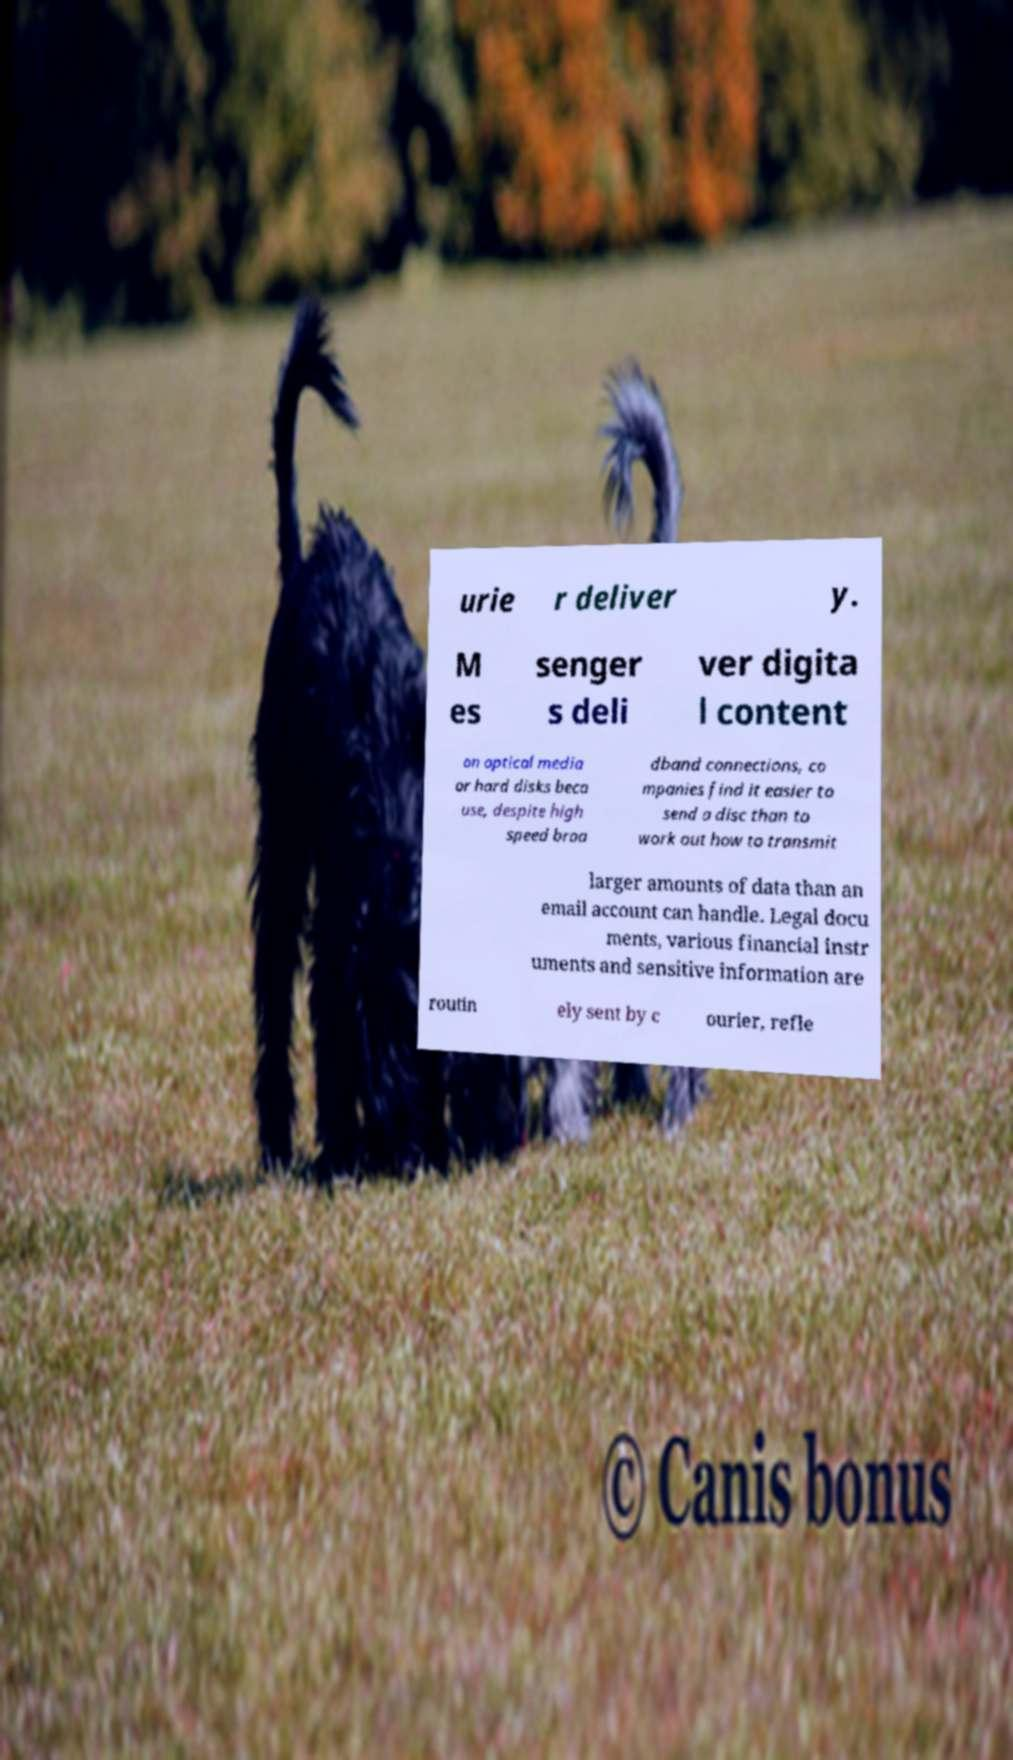I need the written content from this picture converted into text. Can you do that? urie r deliver y. M es senger s deli ver digita l content on optical media or hard disks beca use, despite high speed broa dband connections, co mpanies find it easier to send a disc than to work out how to transmit larger amounts of data than an email account can handle. Legal docu ments, various financial instr uments and sensitive information are routin ely sent by c ourier, refle 